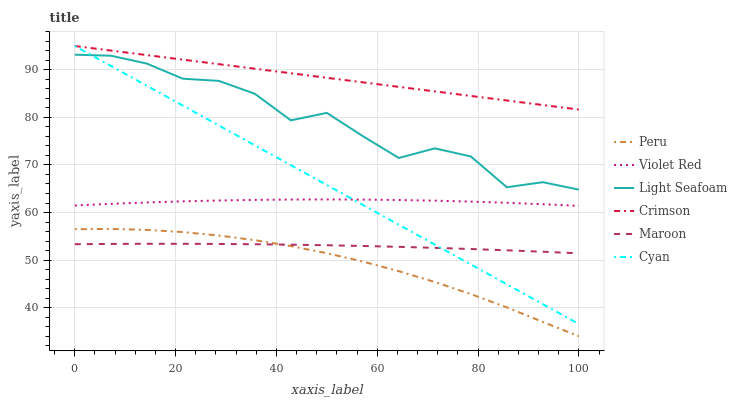Does Maroon have the minimum area under the curve?
Answer yes or no. No. Does Maroon have the maximum area under the curve?
Answer yes or no. No. Is Maroon the smoothest?
Answer yes or no. No. Is Maroon the roughest?
Answer yes or no. No. Does Maroon have the lowest value?
Answer yes or no. No. Does Peru have the highest value?
Answer yes or no. No. Is Violet Red less than Crimson?
Answer yes or no. Yes. Is Crimson greater than Maroon?
Answer yes or no. Yes. Does Violet Red intersect Crimson?
Answer yes or no. No. 